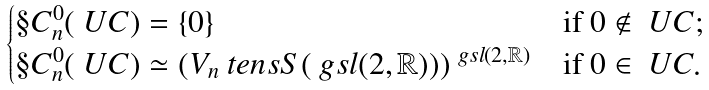Convert formula to latex. <formula><loc_0><loc_0><loc_500><loc_500>\begin{cases} \S C _ { n } ^ { 0 } ( \ U C ) = \{ 0 \} & \text {if } 0 \not \in \ U C ; \\ \S C _ { n } ^ { 0 } ( \ U C ) \simeq ( V _ { n } \ t e n s S ( \ g { s l } ( 2 , \mathbb { R } ) ) ) ^ { \ g { s l } ( 2 , \mathbb { R } ) } & \text {if } 0 \in \ U C . \end{cases}</formula> 